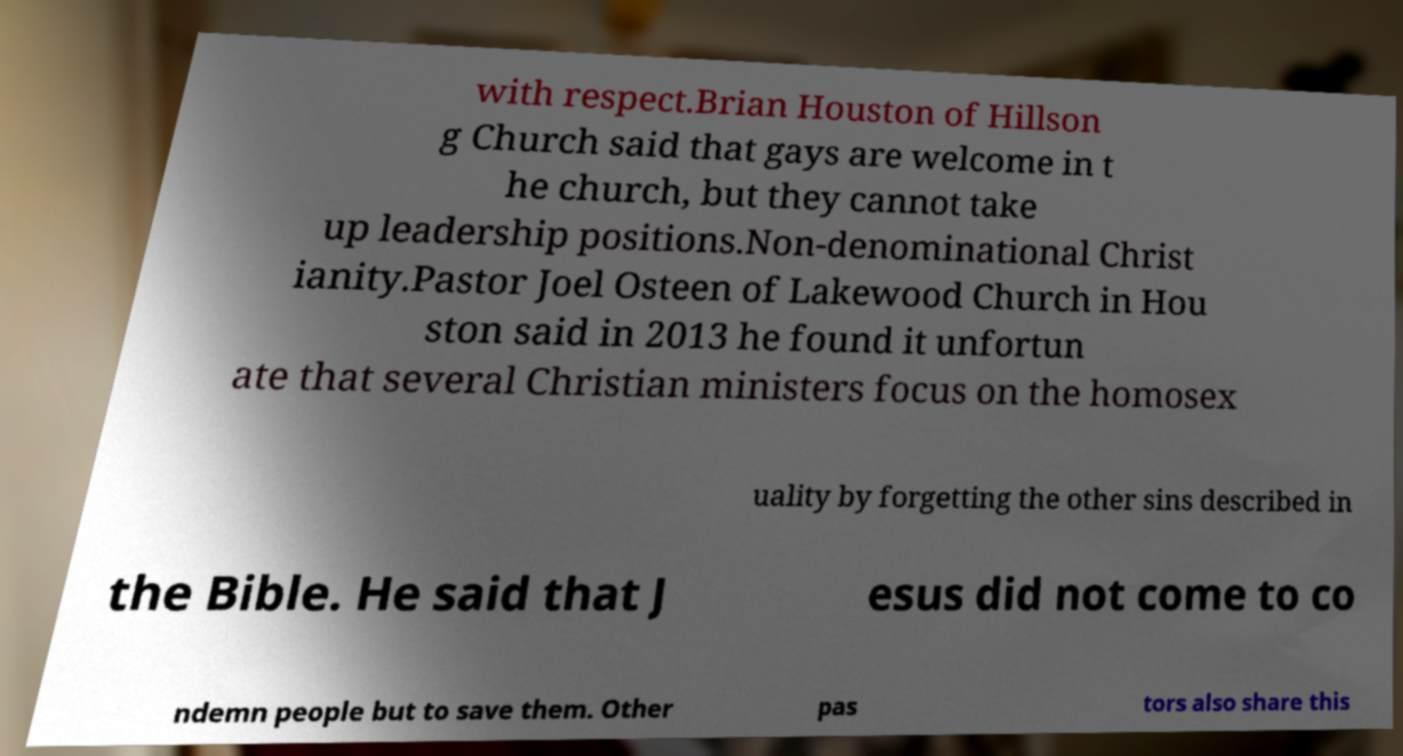For documentation purposes, I need the text within this image transcribed. Could you provide that? with respect.Brian Houston of Hillson g Church said that gays are welcome in t he church, but they cannot take up leadership positions.Non-denominational Christ ianity.Pastor Joel Osteen of Lakewood Church in Hou ston said in 2013 he found it unfortun ate that several Christian ministers focus on the homosex uality by forgetting the other sins described in the Bible. He said that J esus did not come to co ndemn people but to save them. Other pas tors also share this 